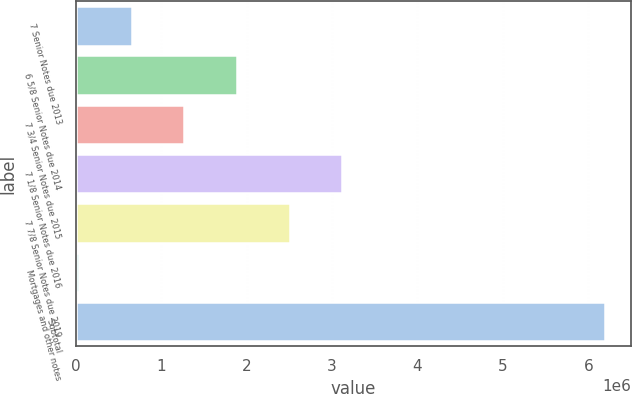<chart> <loc_0><loc_0><loc_500><loc_500><bar_chart><fcel>7 Senior Notes due 2013<fcel>6 5/8 Senior Notes due 2014<fcel>7 3/4 Senior Notes due 2015<fcel>7 1/8 Senior Notes due 2016<fcel>7 7/8 Senior Notes due 2019<fcel>Mortgages and other notes<fcel>Subtotal<nl><fcel>657107<fcel>1.88711e+06<fcel>1.27211e+06<fcel>3.11711e+06<fcel>2.50211e+06<fcel>42107<fcel>6.19211e+06<nl></chart> 